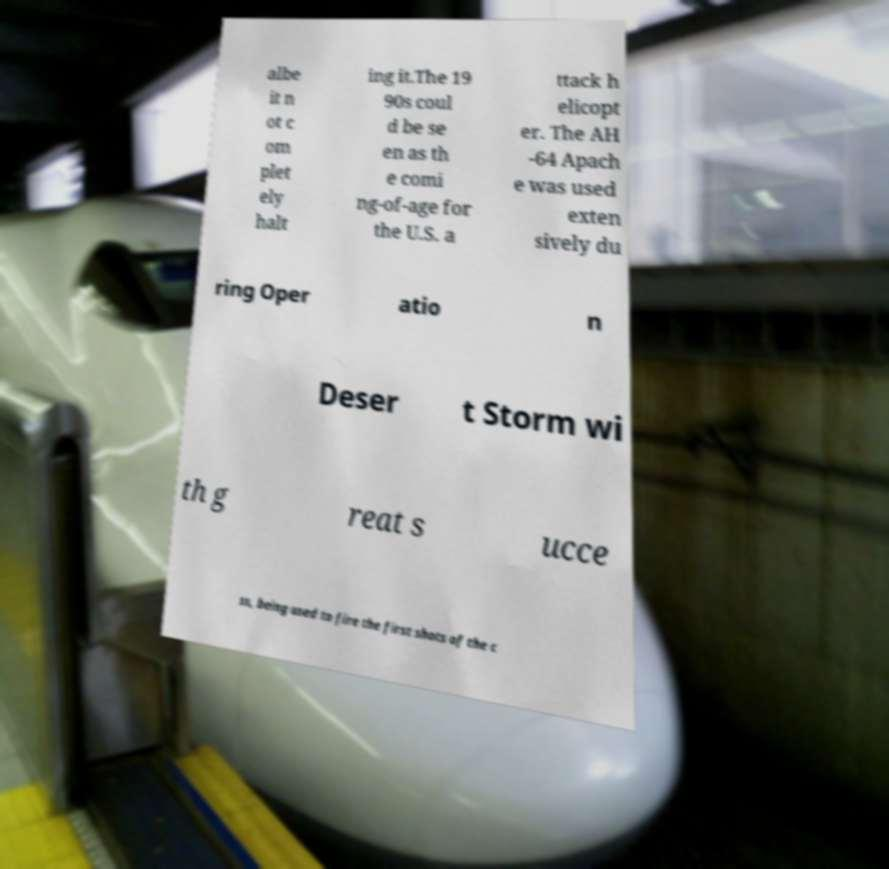Could you assist in decoding the text presented in this image and type it out clearly? albe it n ot c om plet ely halt ing it.The 19 90s coul d be se en as th e comi ng-of-age for the U.S. a ttack h elicopt er. The AH -64 Apach e was used exten sively du ring Oper atio n Deser t Storm wi th g reat s ucce ss, being used to fire the first shots of the c 